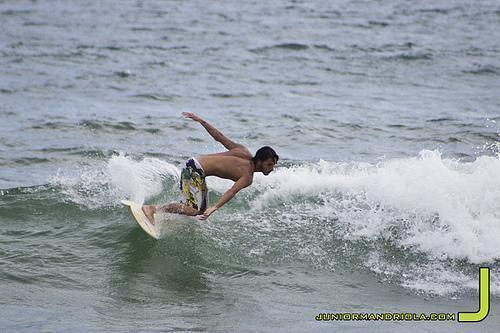How many men are there?
Give a very brief answer. 1. 